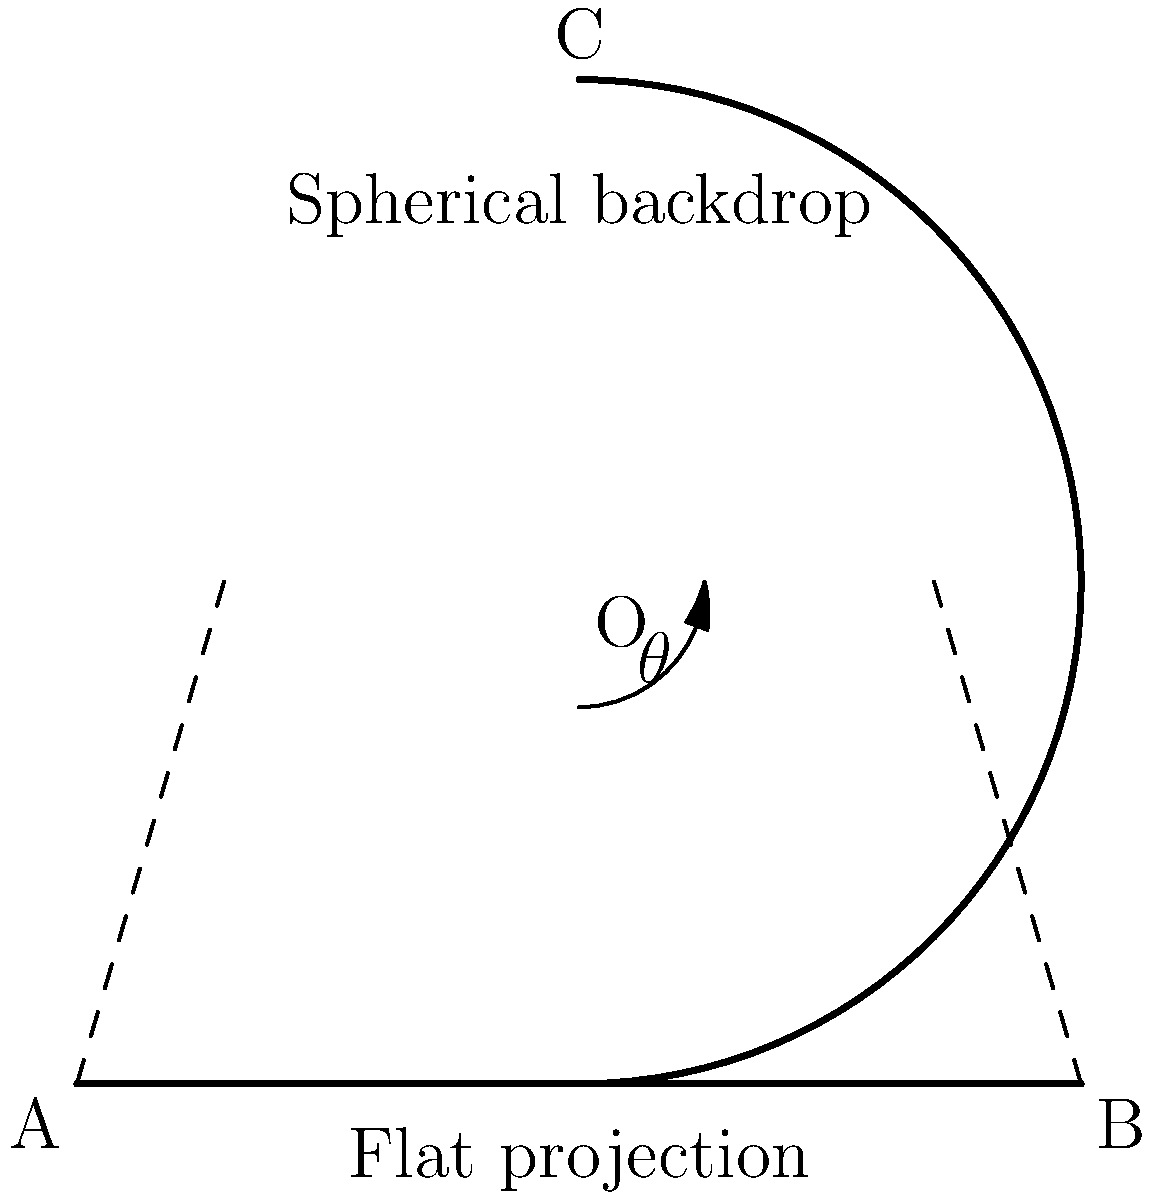You're designing a set with a spherical backdrop for a TV show. The backdrop needs to be projected onto a flat screen for a visual effect. If the spherical backdrop has a radius of 2 meters and spans an arc of 180°, what is the length of the flat projection screen needed to maintain the same visual angle $\theta$ for the audience? To solve this problem, we need to follow these steps:

1) First, let's understand what we're given:
   - The spherical backdrop has a radius (r) of 2 meters
   - It spans an arc of 180° (half a circle)
   - We need to maintain the same visual angle $\theta$

2) The length of the arc of the spherical backdrop is given by:
   $L_{arc} = r\theta$
   Where $\theta$ is in radians. For a half-circle, $\theta = \pi$ radians.
   So, $L_{arc} = 2\pi = 6.28$ meters

3) Now, we need to find the length of the flat projection that subtends the same angle $\theta$ at the center.

4) In a right triangle formed by half of the flat projection and the radius to the center:
   $\tan(\frac{\theta}{2}) = \frac{x}{r}$
   Where x is half the length of the flat projection.

5) We know that $\theta = \pi$ radians (180°), so:
   $\tan(\frac{\pi}{2}) = \frac{x}{2}$

6) $\tan(\frac{\pi}{2})$ approaches infinity, which means x also approaches infinity.

7) However, in practical terms, we can't have an infinitely long projection screen. We need to choose a finite length that provides a close approximation.

8) A common approximation is to use the length of the chord of the arc:
   $L_{chord} = 2r\sin(\frac{\theta}{2}) = 2(2)\sin(\frac{\pi}{2}) = 4$ meters

This chord length will provide a very close approximation to the visual angle of the original spherical backdrop for most of the audience.
Answer: 4 meters 